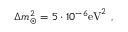Convert formula to latex. <formula><loc_0><loc_0><loc_500><loc_500>\Delta m _ { \odot } ^ { 2 } = 5 \cdot 1 0 ^ { - 6 } e V ^ { 2 } ,</formula> 